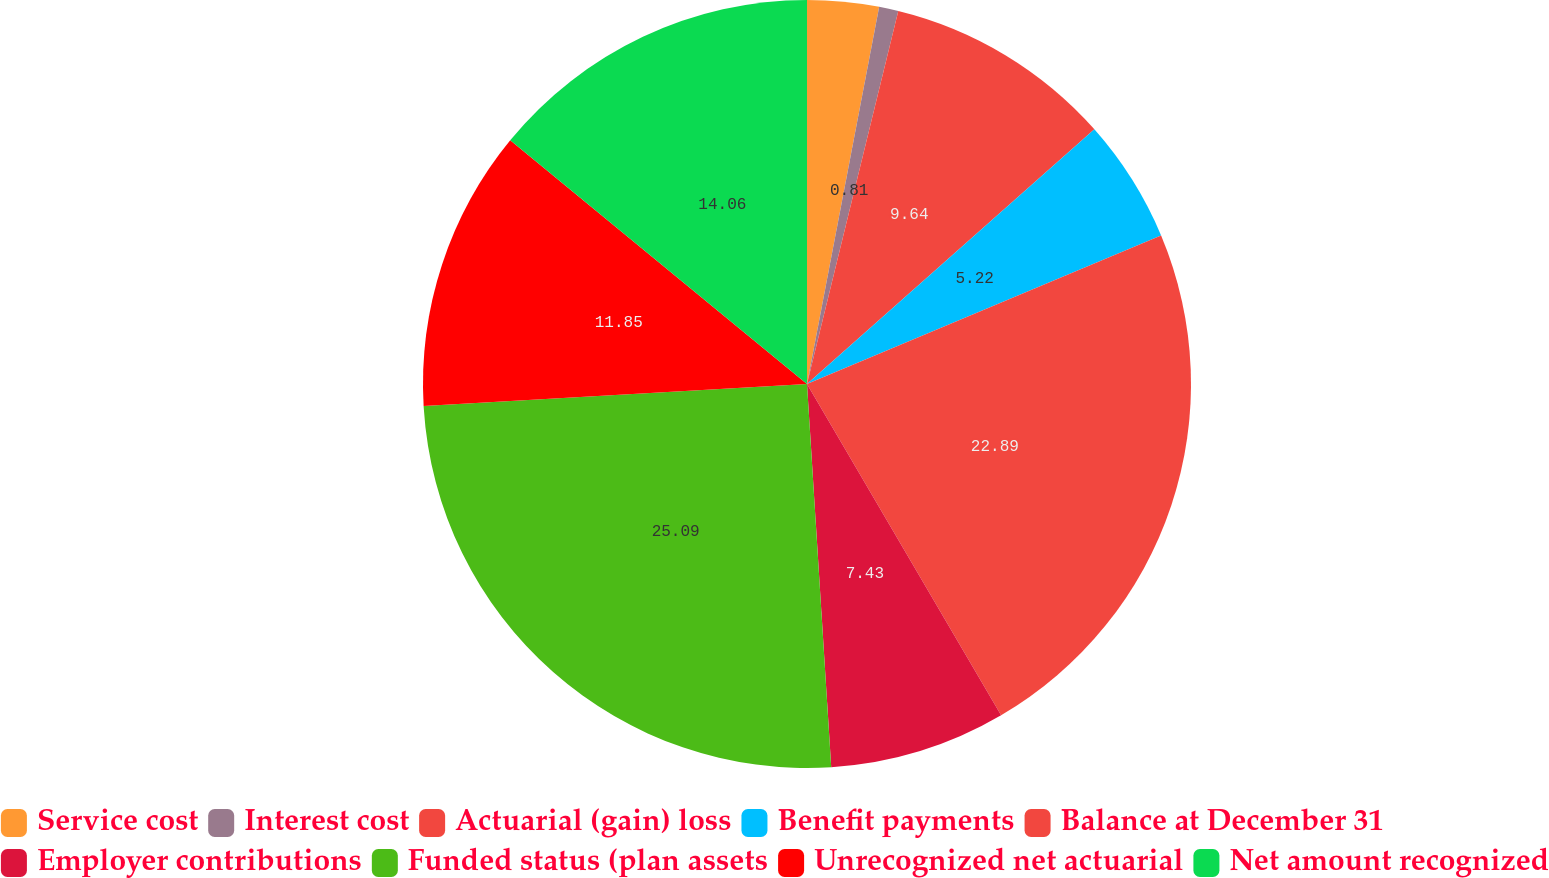Convert chart to OTSL. <chart><loc_0><loc_0><loc_500><loc_500><pie_chart><fcel>Service cost<fcel>Interest cost<fcel>Actuarial (gain) loss<fcel>Benefit payments<fcel>Balance at December 31<fcel>Employer contributions<fcel>Funded status (plan assets<fcel>Unrecognized net actuarial<fcel>Net amount recognized<nl><fcel>3.01%<fcel>0.81%<fcel>9.64%<fcel>5.22%<fcel>22.89%<fcel>7.43%<fcel>25.1%<fcel>11.85%<fcel>14.06%<nl></chart> 